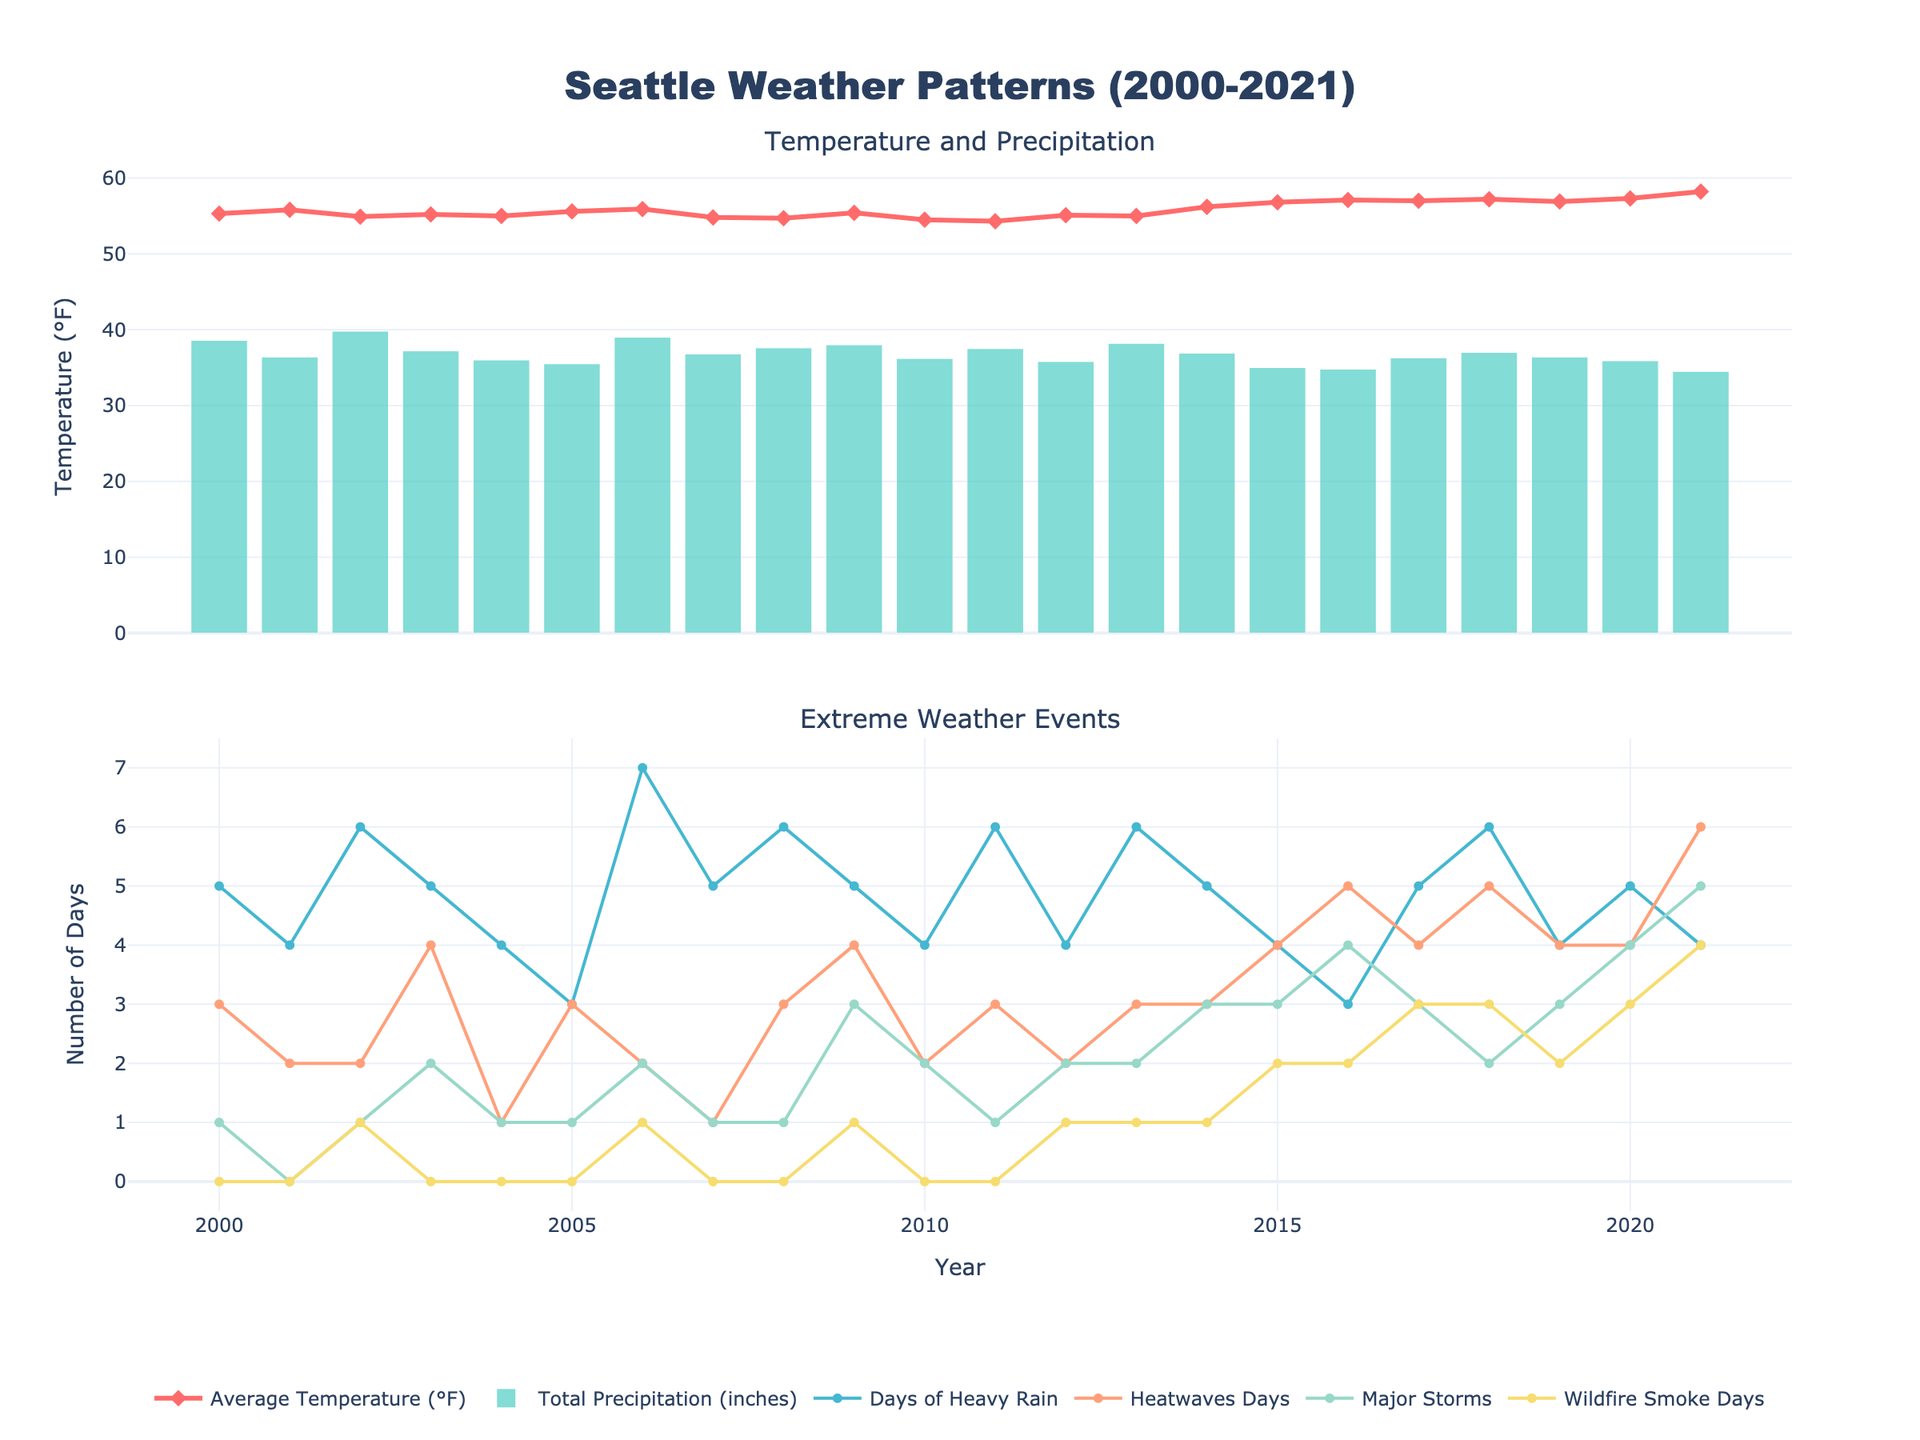What's the average temperature in 2005? Look at the first subplot and find the data point for the year 2005 under the "Average Temperature (°F)" line. The value is 55.6°F.
Answer: 55.6°F How many days of heatwaves were there in 2021? In the second subplot, find the data point for the year 2021 under the "Heatwaves Days" line. The value is 6 days.
Answer: 6 days Which year had the highest total precipitation? In the first subplot, look at the "Total Precipitation (inches)" bar. The highest bar is in 2002, which had the highest total precipitation.
Answer: 2002 What's the difference in average temperature between 2000 and 2021? Find the average temperatures for 2000 and 2021 in the first subplot. In 2000, it's 55.3°F, and in 2021, it's 58.2°F. The difference is 58.2 - 55.3 = 2.9°F.
Answer: 2.9°F In which year did the number of wildfire smoke days first exceed 1? In the second subplot, look at the "Wildfire Smoke Days" line. The first time it exceeds 1 is in 2006, with a value of 1 day.
Answer: 2006 Over the years, did the number of major storms show an increasing trend? Examine the "Major Storms" line in the second subplot. Observe the trend: it starts at 1 in 2000, fluctuates, but by 2021 it increases to 5. The trend is increasing.
Answer: Yes Which extreme weather event had the most fluctuations between 2000 and 2021? Compare the lines for "Days of Heavy Rain," "Heatwaves Days," "Major Storms," and "Wildfire Smoke Days" in the second subplot. "Days of Heavy Rain" and "Heatwaves Days" show more noticeable fluctuations over the years.
Answer: Heatwaves Days What's the total number of wildfire smoke days from 2000 to 2021? Sum all the values in the "Wildfire Smoke Days" line from 2000 to 2021: 0+0+1+0+0+0+1+0+0+1+0+0+1+1+1+2+2+3+2+3+4 = 21 days.
Answer: 21 days Which year had the highest number of days of heavy rain? Examine the "Days of Heavy Rain" line in the second subplot. The highest value is in 2006 with 7 days.
Answer: 2006 In which year did Seattle experience both high heatwave days and major storms? Look for years where both "Heatwaves Days" and "Major Storms" are relatively high. In 2021, both are at their peak with 6 and 5 days, respectively.
Answer: 2021 